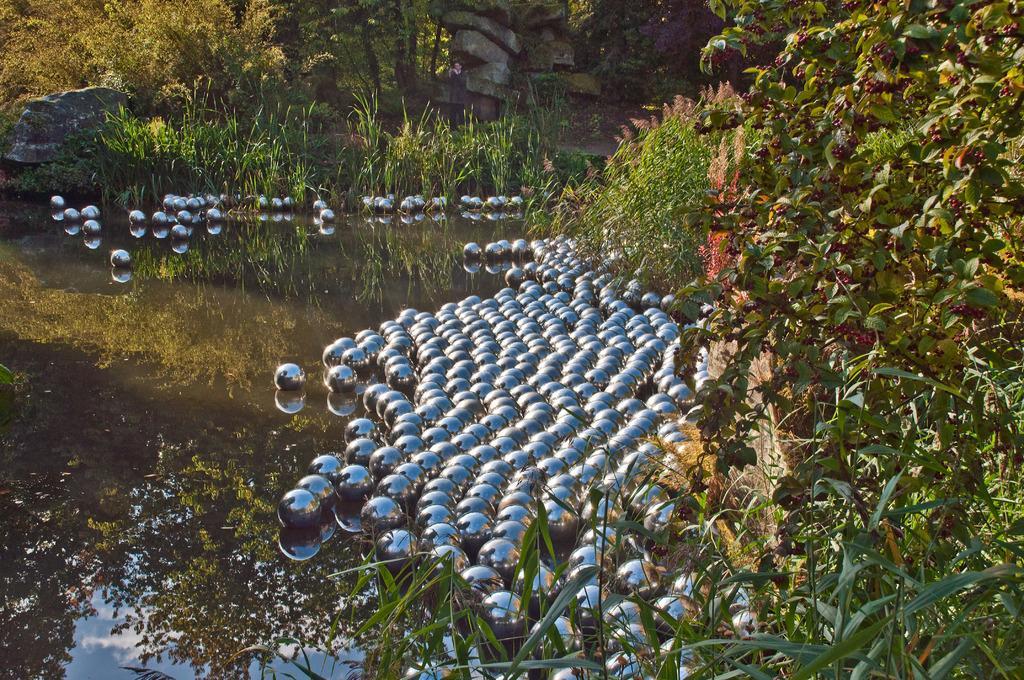In one or two sentences, can you explain what this image depicts? Here we can see water. There are balls, plants, trees, and rocks. 